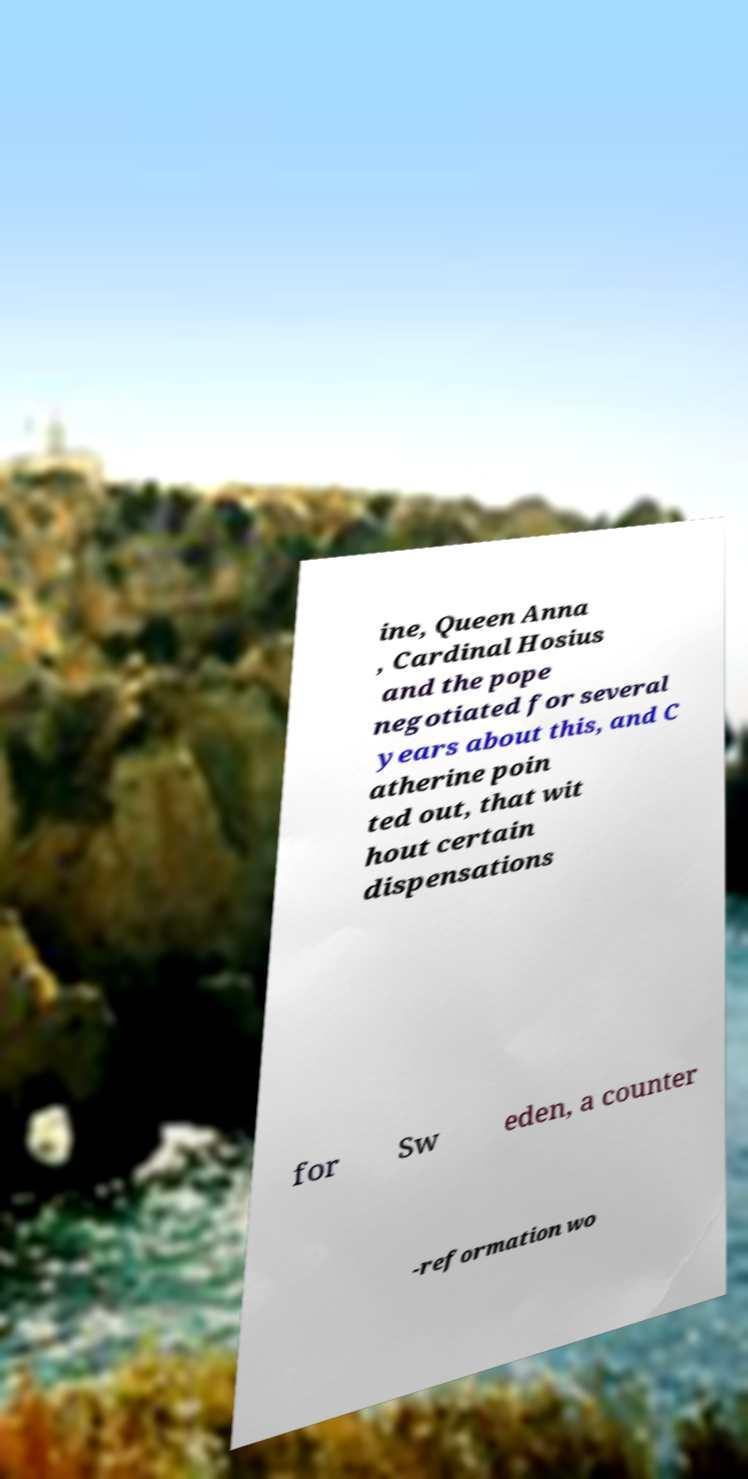Please read and relay the text visible in this image. What does it say? ine, Queen Anna , Cardinal Hosius and the pope negotiated for several years about this, and C atherine poin ted out, that wit hout certain dispensations for Sw eden, a counter -reformation wo 